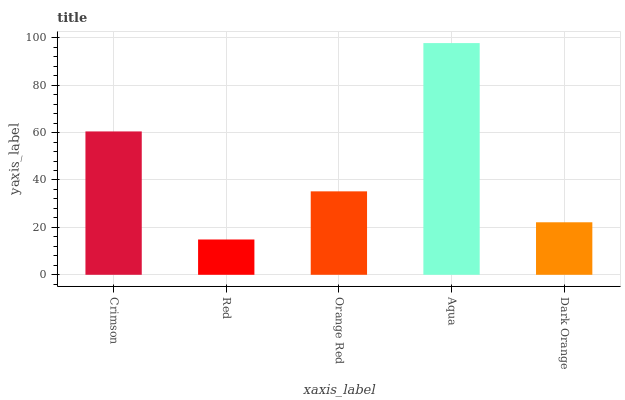Is Red the minimum?
Answer yes or no. Yes. Is Aqua the maximum?
Answer yes or no. Yes. Is Orange Red the minimum?
Answer yes or no. No. Is Orange Red the maximum?
Answer yes or no. No. Is Orange Red greater than Red?
Answer yes or no. Yes. Is Red less than Orange Red?
Answer yes or no. Yes. Is Red greater than Orange Red?
Answer yes or no. No. Is Orange Red less than Red?
Answer yes or no. No. Is Orange Red the high median?
Answer yes or no. Yes. Is Orange Red the low median?
Answer yes or no. Yes. Is Aqua the high median?
Answer yes or no. No. Is Dark Orange the low median?
Answer yes or no. No. 